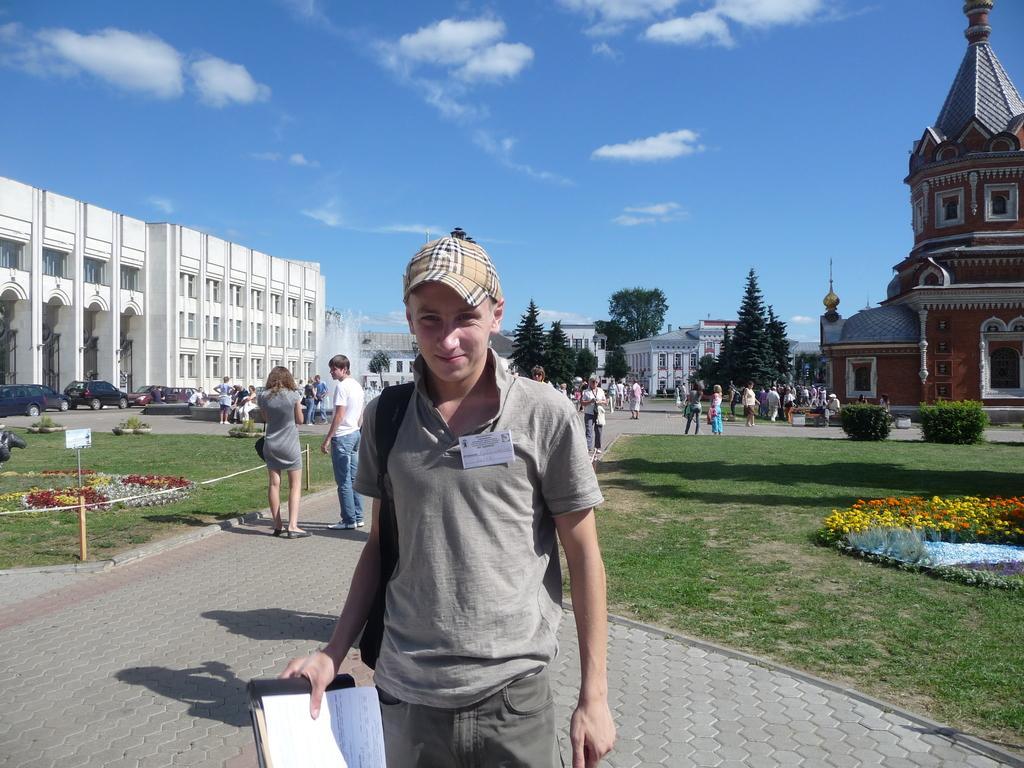Please provide a concise description of this image. In this image we can see a group of people standing on the floor. One person wearing a cap and a book in his hand. One woman wearing grey dress is carrying a bag. In the background, we can see group of flowers, plants, trees, buildings and vehicles parked on the ground and the cloudy sky. 